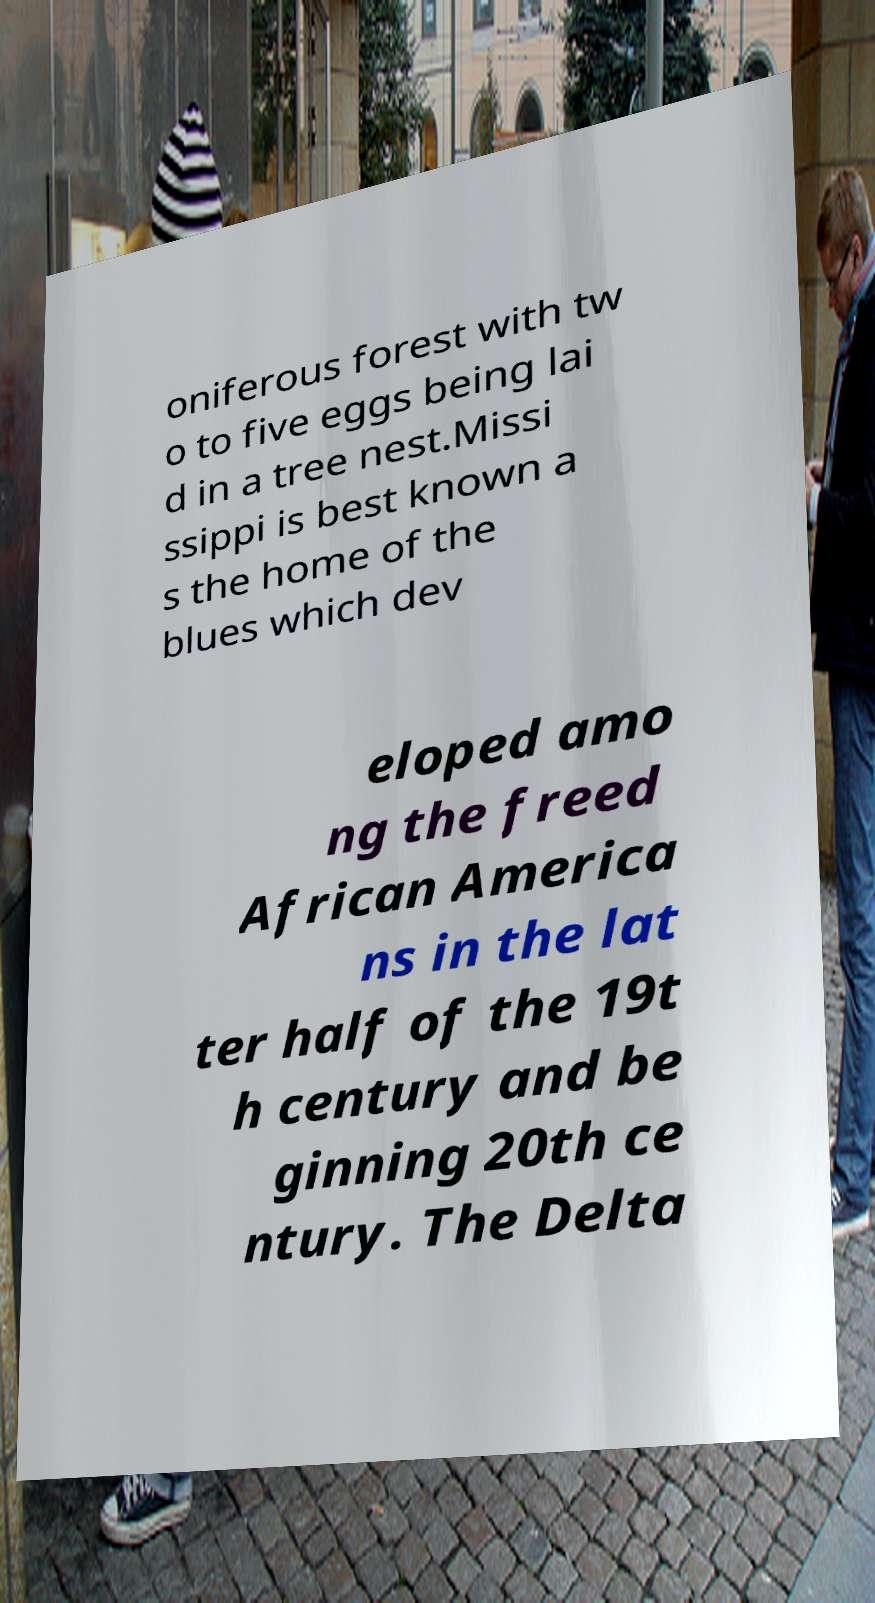What messages or text are displayed in this image? I need them in a readable, typed format. oniferous forest with tw o to five eggs being lai d in a tree nest.Missi ssippi is best known a s the home of the blues which dev eloped amo ng the freed African America ns in the lat ter half of the 19t h century and be ginning 20th ce ntury. The Delta 